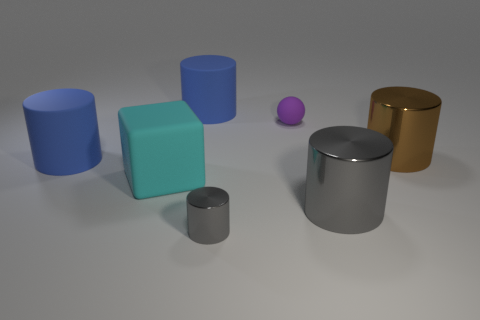What shape is the thing that is right of the tiny gray thing and behind the large brown thing?
Your answer should be compact. Sphere. What number of large objects are either red cylinders or brown metal cylinders?
Keep it short and to the point. 1. Are there an equal number of cyan matte things that are in front of the cyan cube and matte spheres that are in front of the tiny gray object?
Provide a succinct answer. Yes. How many other things are the same color as the small cylinder?
Keep it short and to the point. 1. Are there an equal number of gray metallic cylinders right of the small cylinder and red cylinders?
Your answer should be very brief. No. Is the size of the brown shiny object the same as the rubber sphere?
Give a very brief answer. No. The cylinder that is both in front of the brown object and behind the large gray thing is made of what material?
Offer a terse response. Rubber. What number of large gray metal objects have the same shape as the brown object?
Your answer should be compact. 1. There is a big blue object behind the small rubber object; what material is it?
Make the answer very short. Rubber. Are there fewer tiny purple rubber balls that are behind the large gray object than metallic things?
Offer a very short reply. Yes. 